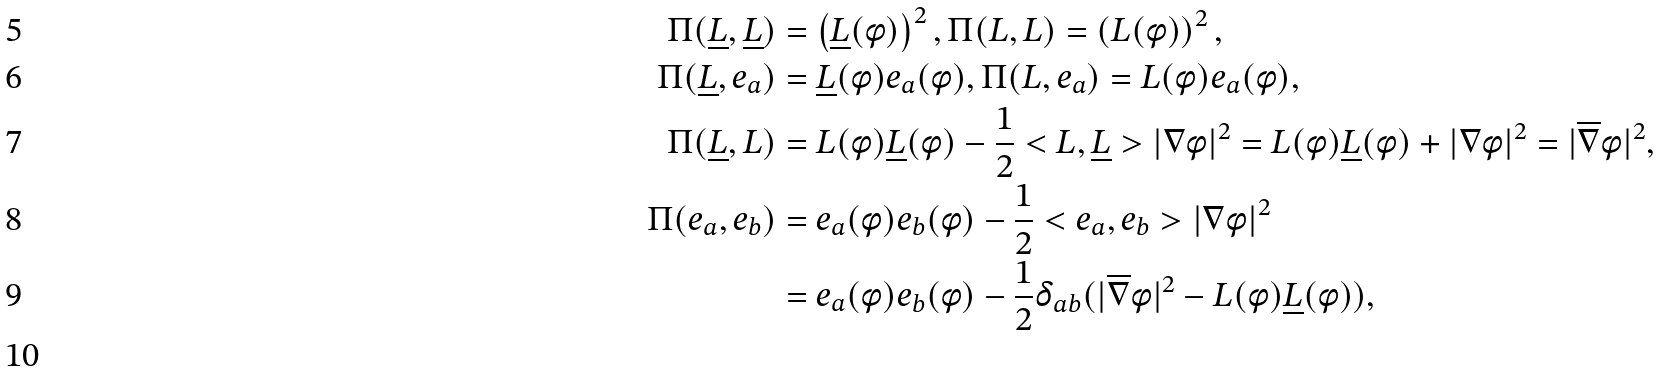Convert formula to latex. <formula><loc_0><loc_0><loc_500><loc_500>\Pi ( \underline { L } , \underline { L } ) & = \left ( \underline { L } ( \phi ) \right ) ^ { 2 } , \Pi ( L , L ) = \left ( L ( \phi ) \right ) ^ { 2 } , \\ \Pi ( \underline { L } , e _ { a } ) & = \underline { L } ( \phi ) e _ { a } ( \phi ) , \Pi ( L , e _ { a } ) = L ( \phi ) e _ { a } ( \phi ) , \\ \Pi ( \underline { L } , L ) & = L ( \phi ) \underline { L } ( \phi ) - \frac { 1 } { 2 } < L , \underline { L } > | \nabla \phi | ^ { 2 } = L ( \phi ) \underline { L } ( \phi ) + | \nabla \phi | ^ { 2 } = | \overline { \nabla } \phi | ^ { 2 } , \\ \Pi ( e _ { a } , e _ { b } ) & = e _ { a } ( \phi ) e _ { b } ( \phi ) - \frac { 1 } { 2 } < e _ { a } , e _ { b } > | \nabla \phi | ^ { 2 } \\ & = e _ { a } ( \phi ) e _ { b } ( \phi ) - \frac { 1 } { 2 } \delta _ { a b } ( | \overline { \nabla } \phi | ^ { 2 } - L ( \phi ) \underline { L } ( \phi ) ) , \\</formula> 